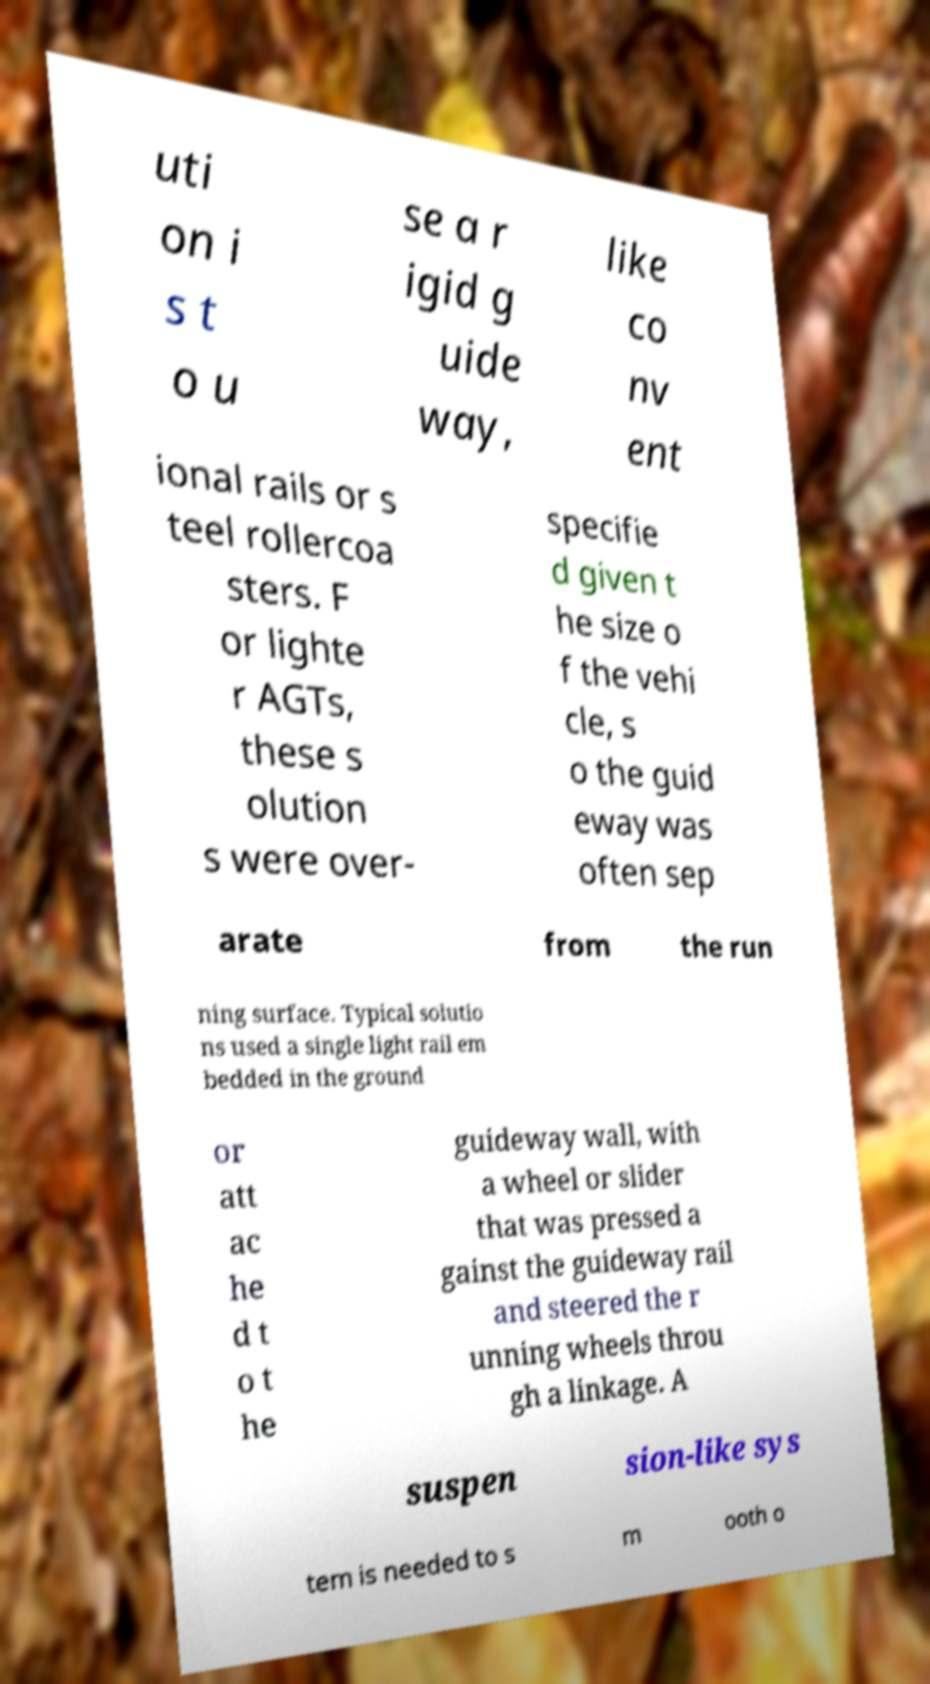What messages or text are displayed in this image? I need them in a readable, typed format. uti on i s t o u se a r igid g uide way, like co nv ent ional rails or s teel rollercoa sters. F or lighte r AGTs, these s olution s were over- specifie d given t he size o f the vehi cle, s o the guid eway was often sep arate from the run ning surface. Typical solutio ns used a single light rail em bedded in the ground or att ac he d t o t he guideway wall, with a wheel or slider that was pressed a gainst the guideway rail and steered the r unning wheels throu gh a linkage. A suspen sion-like sys tem is needed to s m ooth o 